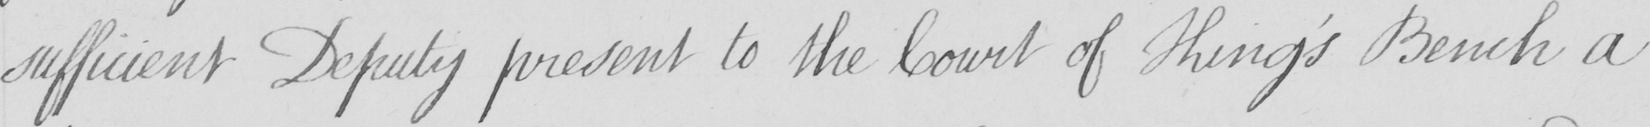What is written in this line of handwriting? sufficient Deputy present to the Court of King ' s Bench a 